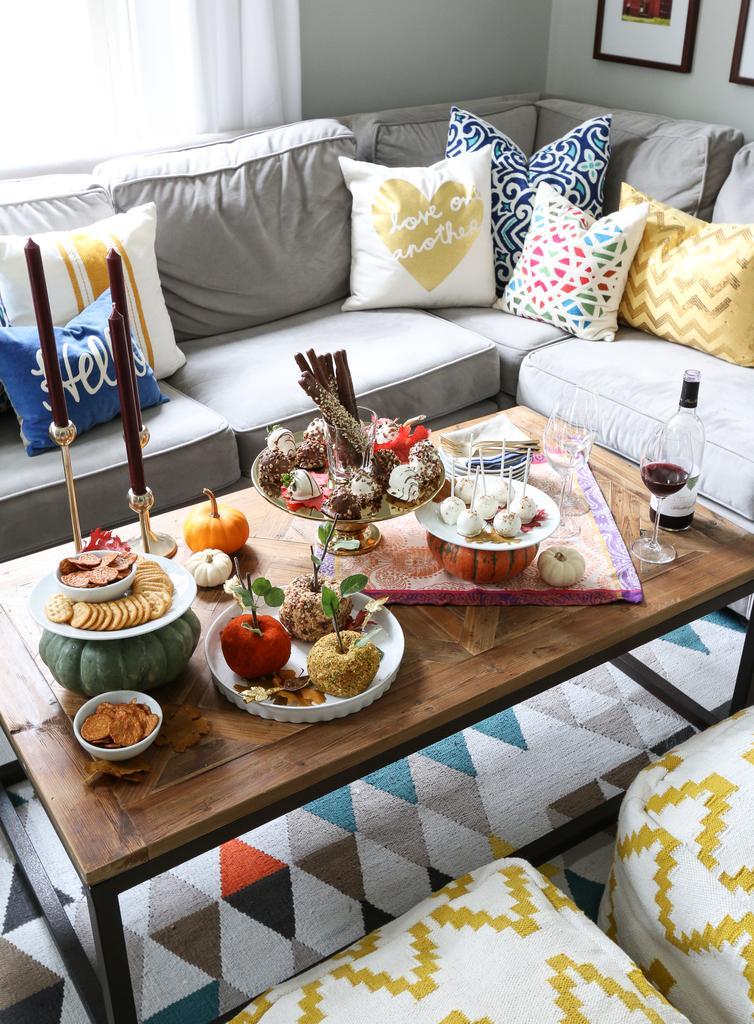Describe this image in one or two sentences. A table on which there are some food items and around the table there are sofas on which there are some pillows. 